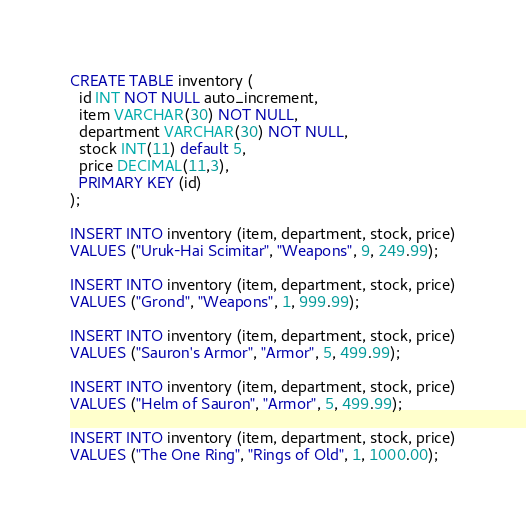<code> <loc_0><loc_0><loc_500><loc_500><_SQL_>
CREATE TABLE inventory (
  id INT NOT NULL auto_increment,
  item VARCHAR(30) NOT NULL,
  department VARCHAR(30) NOT NULL,
  stock INT(11) default 5,
  price DECIMAL(11,3),
  PRIMARY KEY (id)
);

INSERT INTO inventory (item, department, stock, price)
VALUES ("Uruk-Hai Scimitar", "Weapons", 9, 249.99);

INSERT INTO inventory (item, department, stock, price)
VALUES ("Grond", "Weapons", 1, 999.99);

INSERT INTO inventory (item, department, stock, price)
VALUES ("Sauron's Armor", "Armor", 5, 499.99);

INSERT INTO inventory (item, department, stock, price)
VALUES ("Helm of Sauron", "Armor", 5, 499.99);

INSERT INTO inventory (item, department, stock, price)
VALUES ("The One Ring", "Rings of Old", 1, 1000.00);</code> 